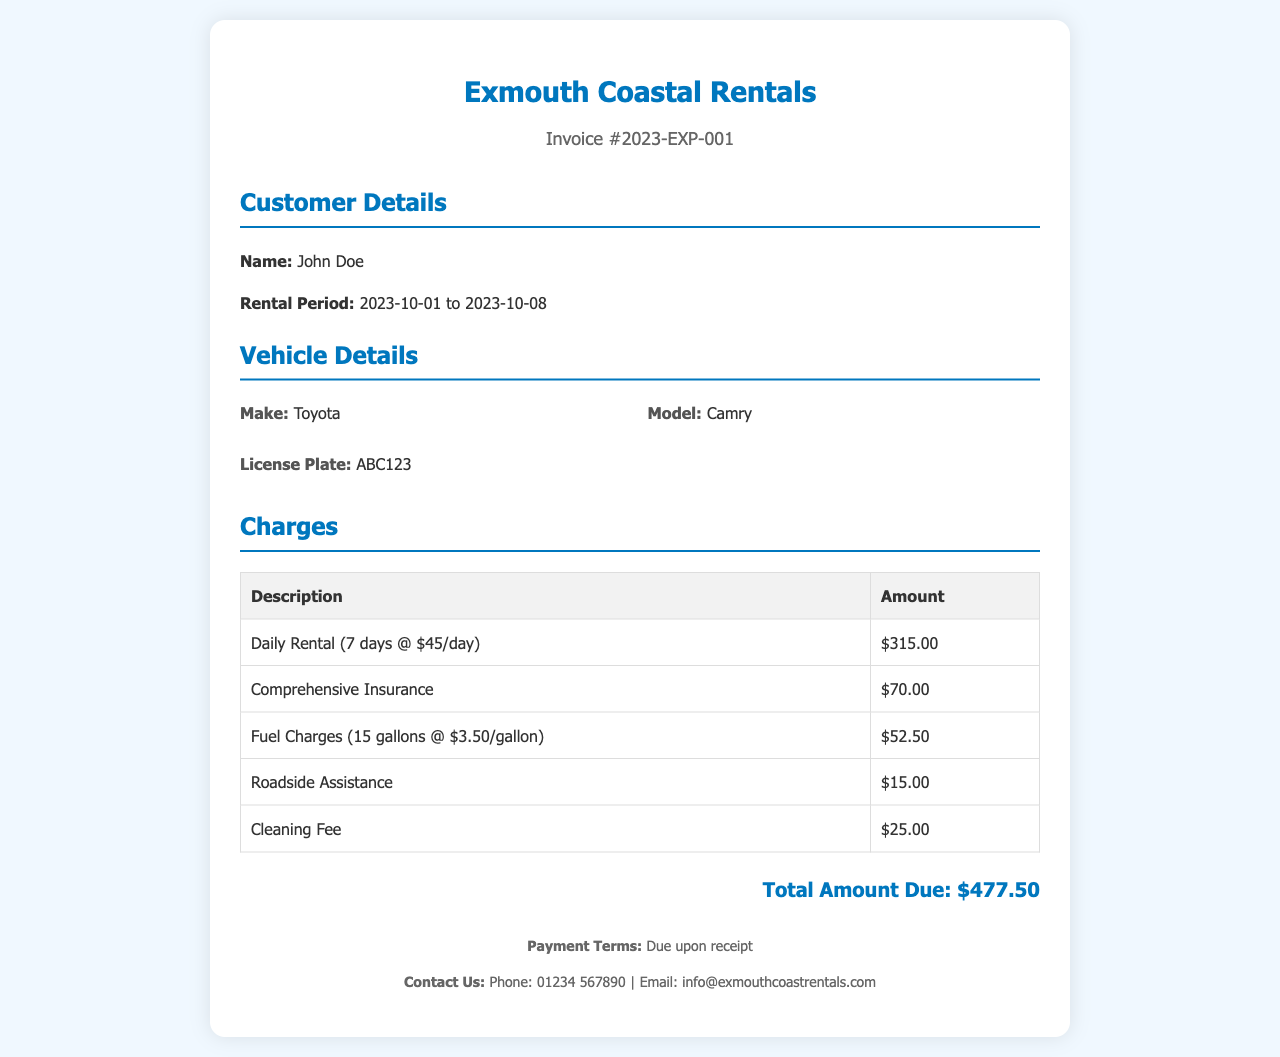What is the rental period? The rental period mentioned in the document is from October 1st to October 8th, 2023.
Answer: 2023-10-01 to 2023-10-08 What is the daily rental rate? The daily rental rate listed in the document is $45 per day.
Answer: $45/day What is the total amount due? The total amount due is calculated from the sum of all charges listed in the invoice.
Answer: $477.50 How many gallons of fuel were charged? The document states that 15 gallons of fuel were charged.
Answer: 15 gallons What company provided the rental service? The service provider mentioned in the invoice is Exmouth Coastal Rentals.
Answer: Exmouth Coastal Rentals What is included in the comprehensive insurance? The document specifies an additional charge for comprehensive insurance but does not detail its contents.
Answer: Comprehensive Insurance How much was charged for cleaning? The charge listed for cleaning in the invoice is $25.00.
Answer: $25.00 What vehicle model was rented? The vehicle model mentioned in the document is Camry.
Answer: Camry What is the contact number for customer service? The contact number provided in the footer of the document is 01234 567890.
Answer: 01234 567890 